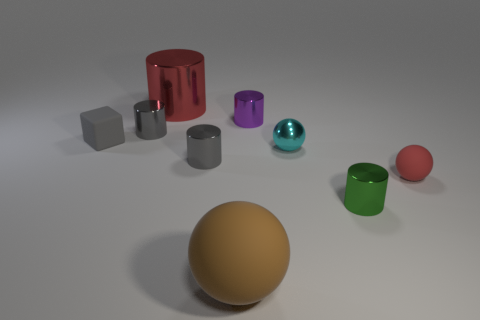What is the shape of the rubber object that is both left of the tiny cyan shiny sphere and to the right of the large red metallic cylinder?
Your response must be concise. Sphere. There is a green cylinder that is the same material as the tiny cyan thing; what is its size?
Make the answer very short. Small. There is a small matte block; is it the same color as the matte object on the right side of the brown rubber ball?
Offer a terse response. No. There is a small cylinder that is behind the cyan ball and on the right side of the big shiny cylinder; what material is it?
Keep it short and to the point. Metal. There is a matte sphere that is the same color as the big cylinder; what size is it?
Keep it short and to the point. Small. There is a tiny rubber object that is on the right side of the purple metal thing; does it have the same shape as the large object behind the large rubber object?
Your answer should be compact. No. Are there any rubber cubes?
Ensure brevity in your answer.  Yes. There is another rubber object that is the same shape as the large matte object; what color is it?
Ensure brevity in your answer.  Red. What color is the shiny thing that is the same size as the brown ball?
Ensure brevity in your answer.  Red. Are the big ball and the purple cylinder made of the same material?
Your answer should be very brief. No. 